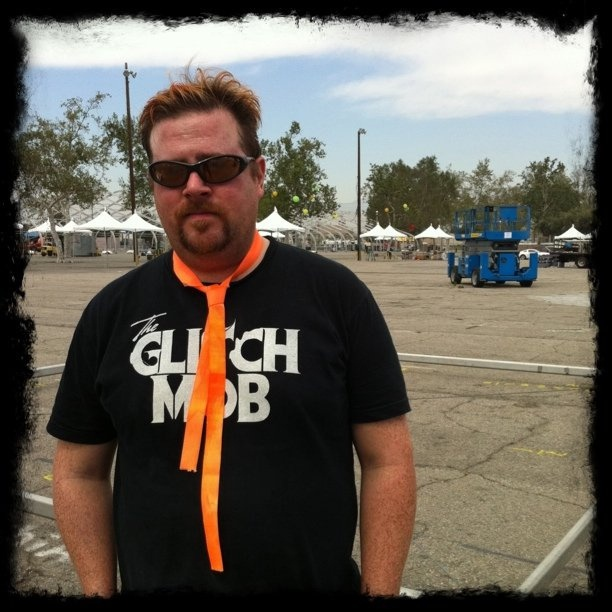Describe the objects in this image and their specific colors. I can see people in black, brown, and maroon tones, tie in black, red, orange, and maroon tones, truck in black, blue, gray, and darkblue tones, truck in black, gray, and darkgray tones, and umbrella in black, ivory, darkgray, gray, and lightgray tones in this image. 